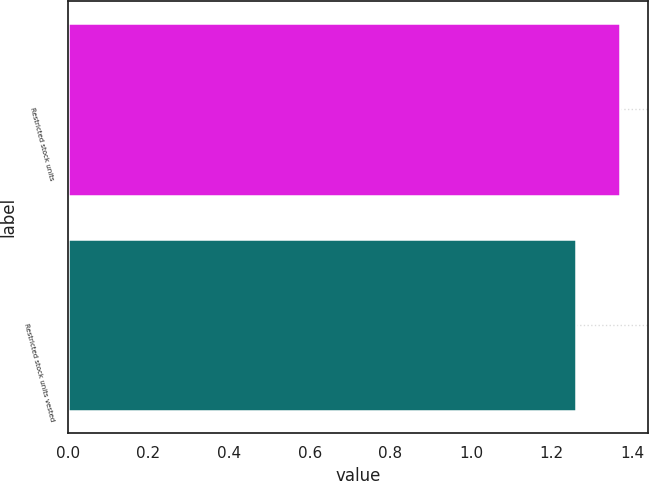Convert chart. <chart><loc_0><loc_0><loc_500><loc_500><bar_chart><fcel>Restricted stock units<fcel>Restricted stock units vested<nl><fcel>1.37<fcel>1.26<nl></chart> 